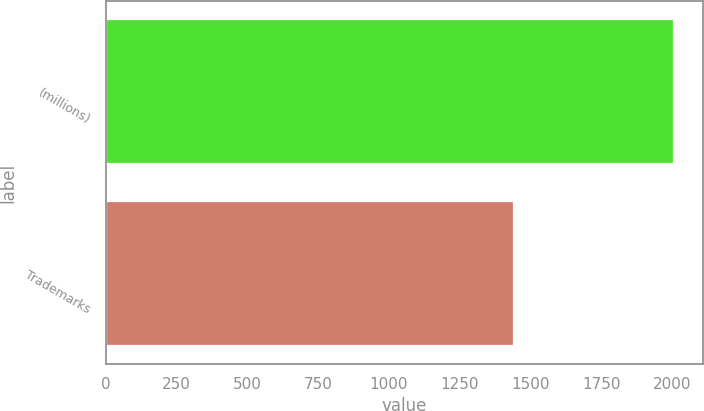Convert chart to OTSL. <chart><loc_0><loc_0><loc_500><loc_500><bar_chart><fcel>(millions)<fcel>Trademarks<nl><fcel>2009<fcel>1443<nl></chart> 